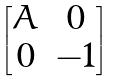<formula> <loc_0><loc_0><loc_500><loc_500>\begin{bmatrix} A & 0 \\ 0 & - 1 \end{bmatrix}</formula> 